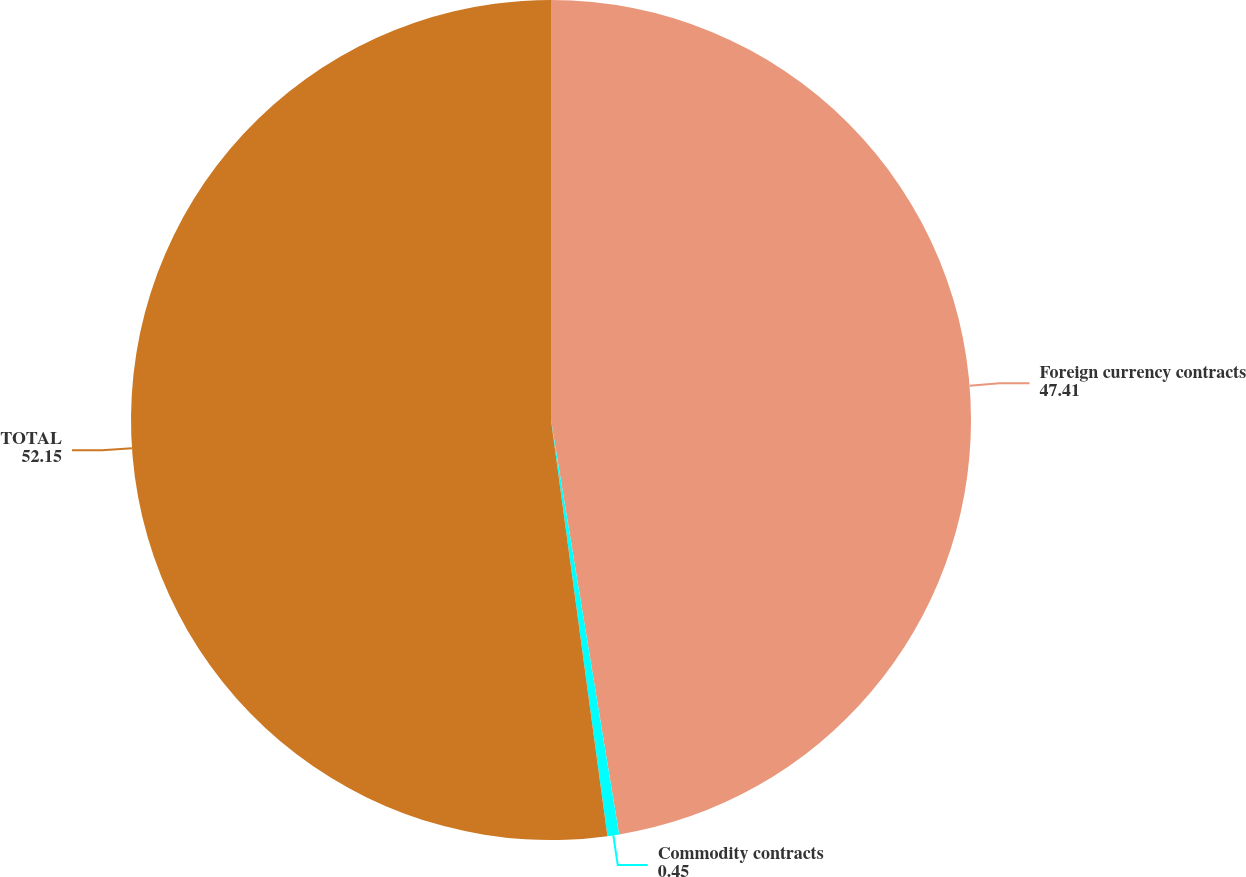<chart> <loc_0><loc_0><loc_500><loc_500><pie_chart><fcel>Foreign currency contracts<fcel>Commodity contracts<fcel>TOTAL<nl><fcel>47.41%<fcel>0.45%<fcel>52.15%<nl></chart> 